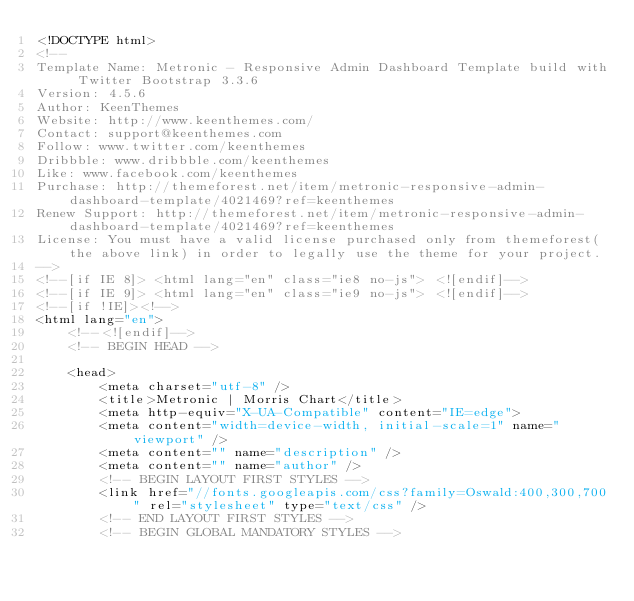Convert code to text. <code><loc_0><loc_0><loc_500><loc_500><_HTML_><!DOCTYPE html>
<!-- 
Template Name: Metronic - Responsive Admin Dashboard Template build with Twitter Bootstrap 3.3.6
Version: 4.5.6
Author: KeenThemes
Website: http://www.keenthemes.com/
Contact: support@keenthemes.com
Follow: www.twitter.com/keenthemes
Dribbble: www.dribbble.com/keenthemes
Like: www.facebook.com/keenthemes
Purchase: http://themeforest.net/item/metronic-responsive-admin-dashboard-template/4021469?ref=keenthemes
Renew Support: http://themeforest.net/item/metronic-responsive-admin-dashboard-template/4021469?ref=keenthemes
License: You must have a valid license purchased only from themeforest(the above link) in order to legally use the theme for your project.
-->
<!--[if IE 8]> <html lang="en" class="ie8 no-js"> <![endif]-->
<!--[if IE 9]> <html lang="en" class="ie9 no-js"> <![endif]-->
<!--[if !IE]><!-->
<html lang="en">
    <!--<![endif]-->
    <!-- BEGIN HEAD -->

    <head>
        <meta charset="utf-8" />
        <title>Metronic | Morris Chart</title>
        <meta http-equiv="X-UA-Compatible" content="IE=edge">
        <meta content="width=device-width, initial-scale=1" name="viewport" />
        <meta content="" name="description" />
        <meta content="" name="author" />
        <!-- BEGIN LAYOUT FIRST STYLES -->
        <link href="//fonts.googleapis.com/css?family=Oswald:400,300,700" rel="stylesheet" type="text/css" />
        <!-- END LAYOUT FIRST STYLES -->
        <!-- BEGIN GLOBAL MANDATORY STYLES --></code> 